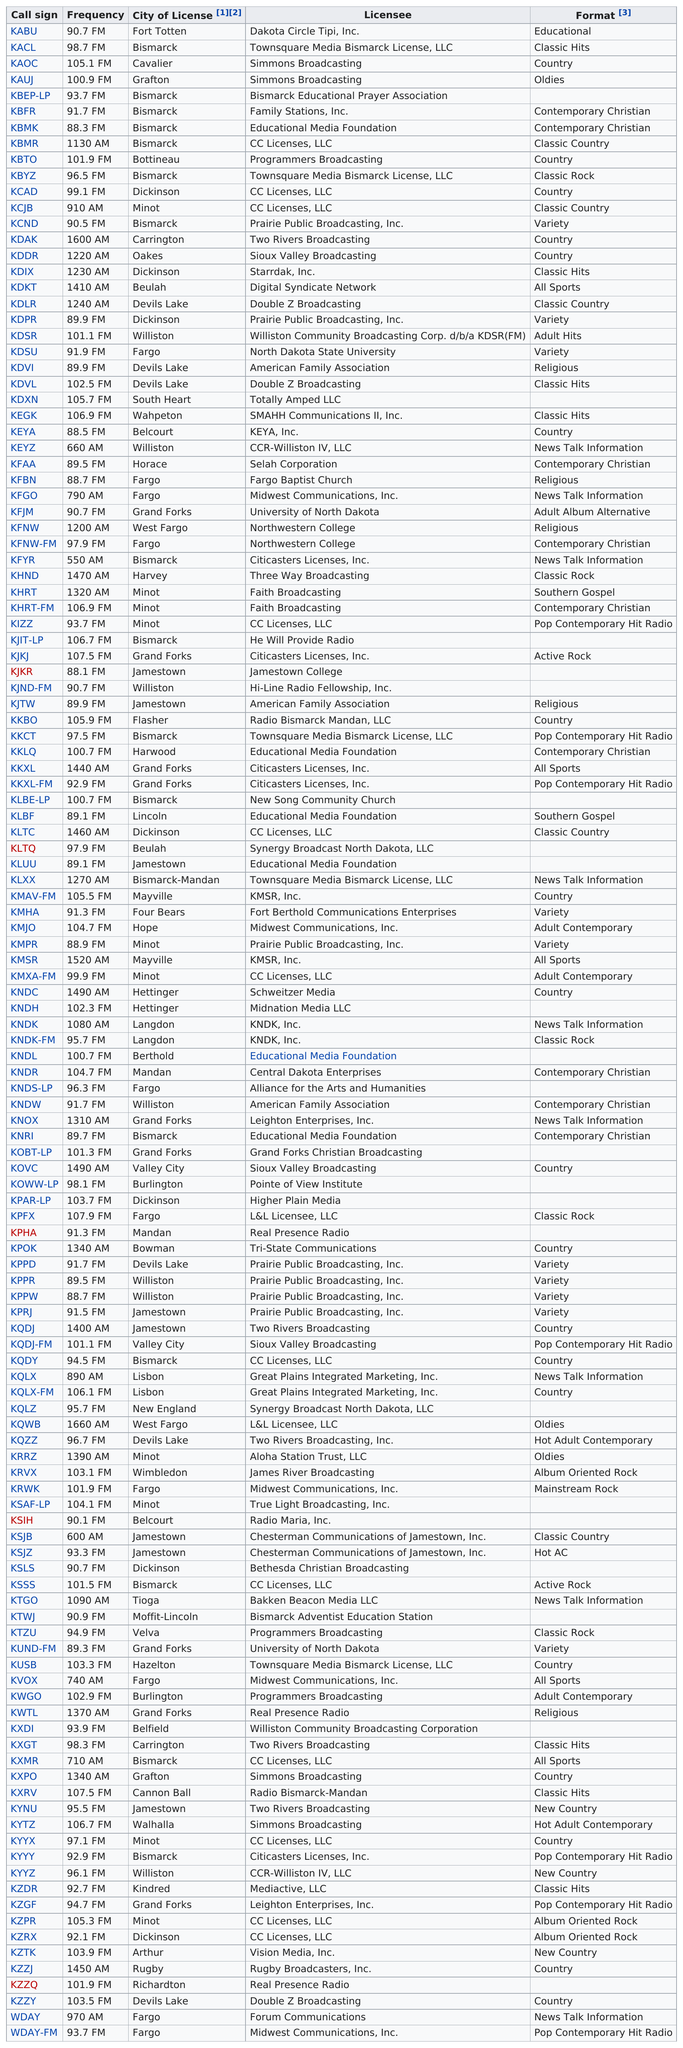Point out several critical features in this image. There is exactly one radio station that has an educational format. What is the first listed news talk information station? It is KEYZ. The call sign listed directly before 'KBMK' is 'KBFR'. The call signs "kbmk" and "kbyz" both have a city of license listed as Bismarck. I name a call sign in Bismarck other than KBFR, KBMK. 